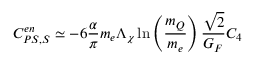Convert formula to latex. <formula><loc_0><loc_0><loc_500><loc_500>C _ { P S , S } ^ { e n } \simeq - 6 \frac { \alpha } { \pi } m _ { e } \Lambda _ { \chi } \ln \left ( \frac { m _ { Q } } { m _ { e } } \right ) \frac { \sqrt { 2 } } { G _ { F } } C _ { 4 }</formula> 